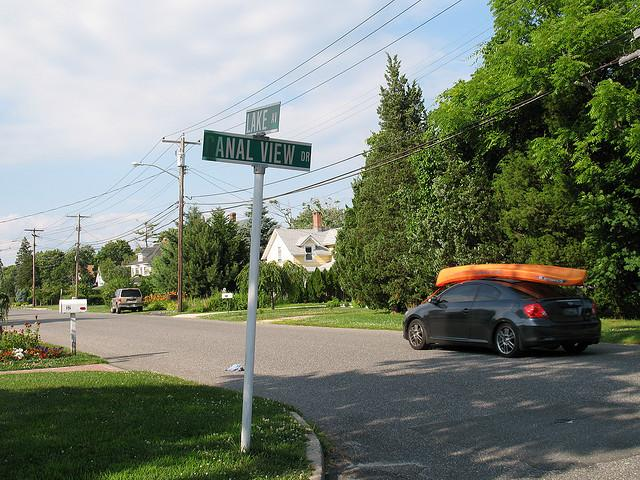What type of tool do you need to move while in the object on top of the black car?

Choices:
A) car keys
B) sun glasses
C) swimming trunks
D) paddle paddle 